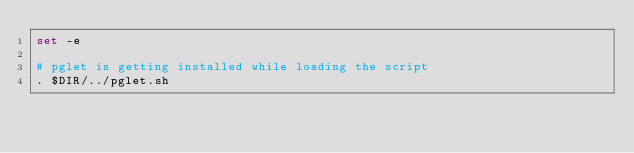<code> <loc_0><loc_0><loc_500><loc_500><_Bash_>set -e

# pglet is getting installed while loading the script
. $DIR/../pglet.sh</code> 